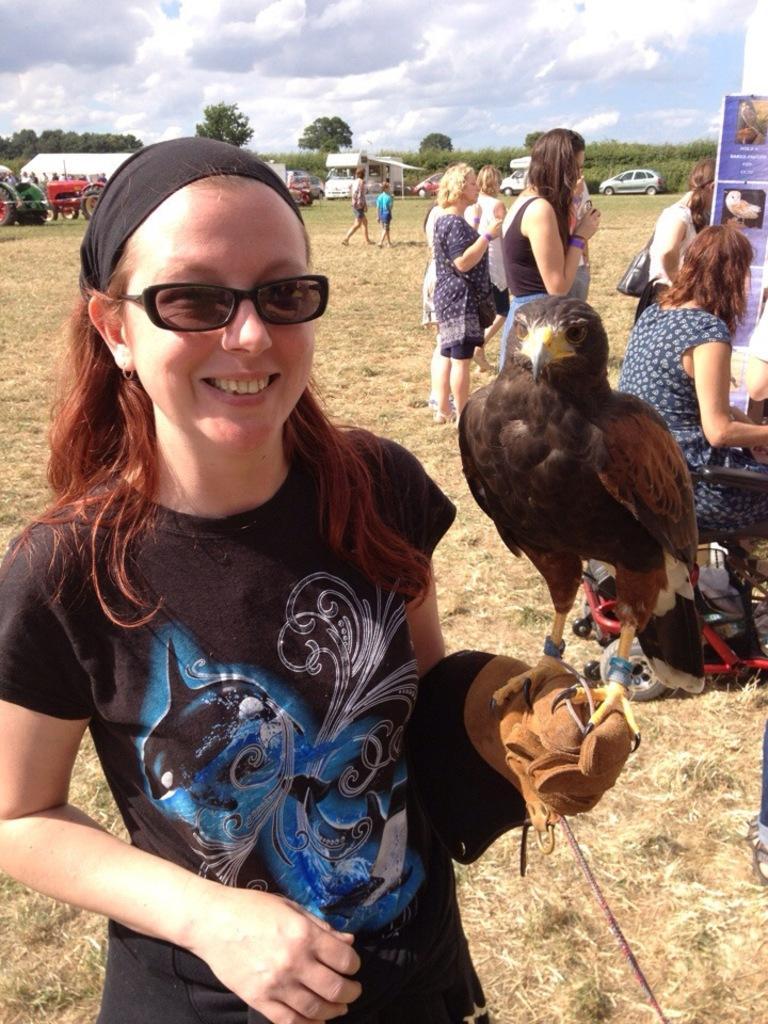How would you summarize this image in a sentence or two? In the picture we can see a woman standing on the ground and on her hand, we can see a bird is standing and she is smiling and she is with a black T-shirt and behind her we can see two women are standing and one woman is sitting near the banner and far away from them, we can see some people are walking and behind them we can see some tractors and some cars are parked and in the background we can see plants, trees, and sky with clouds. 